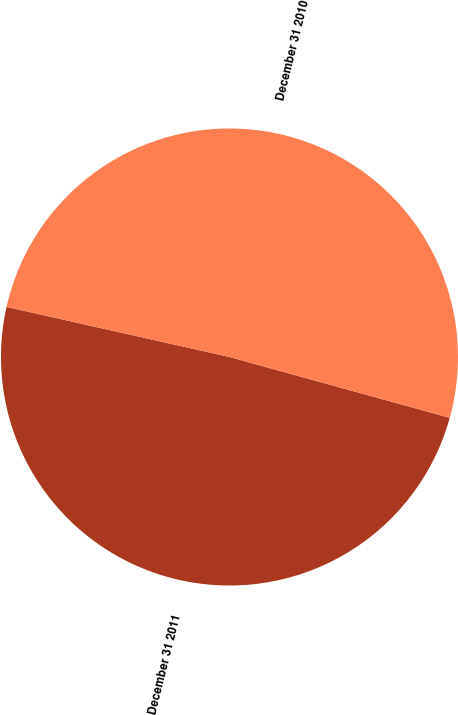<chart> <loc_0><loc_0><loc_500><loc_500><pie_chart><fcel>December 31 2011<fcel>December 31 2010<nl><fcel>49.23%<fcel>50.77%<nl></chart> 